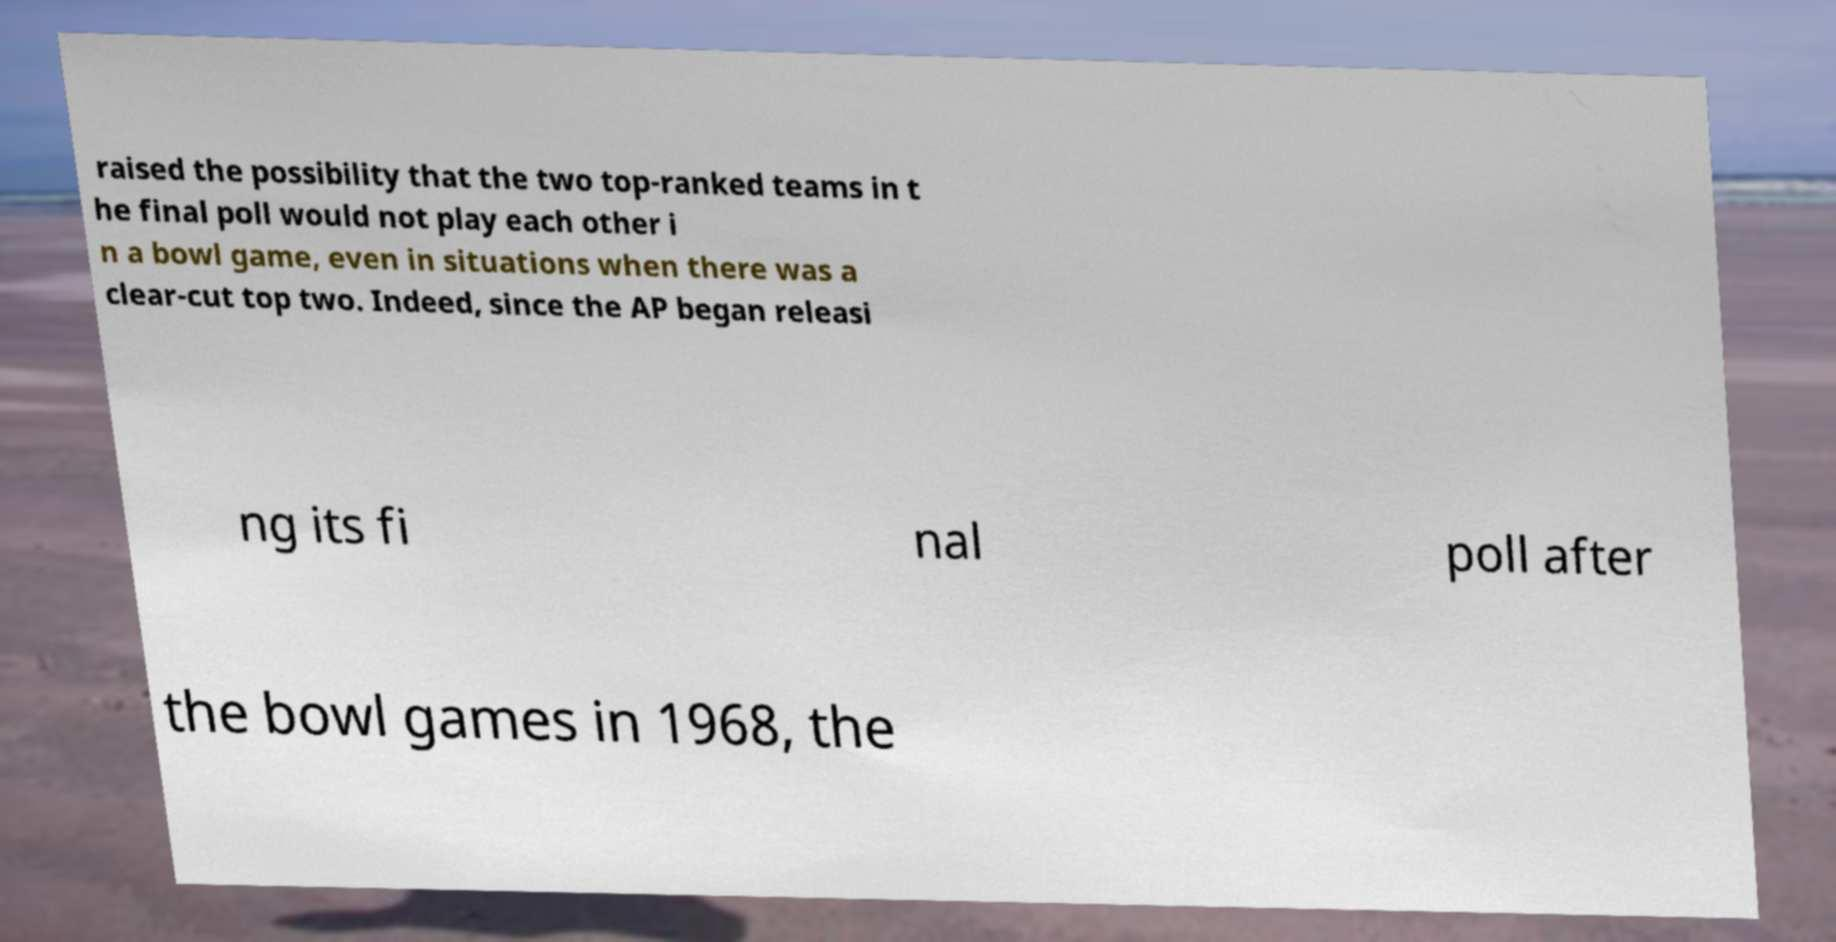There's text embedded in this image that I need extracted. Can you transcribe it verbatim? raised the possibility that the two top-ranked teams in t he final poll would not play each other i n a bowl game, even in situations when there was a clear-cut top two. Indeed, since the AP began releasi ng its fi nal poll after the bowl games in 1968, the 